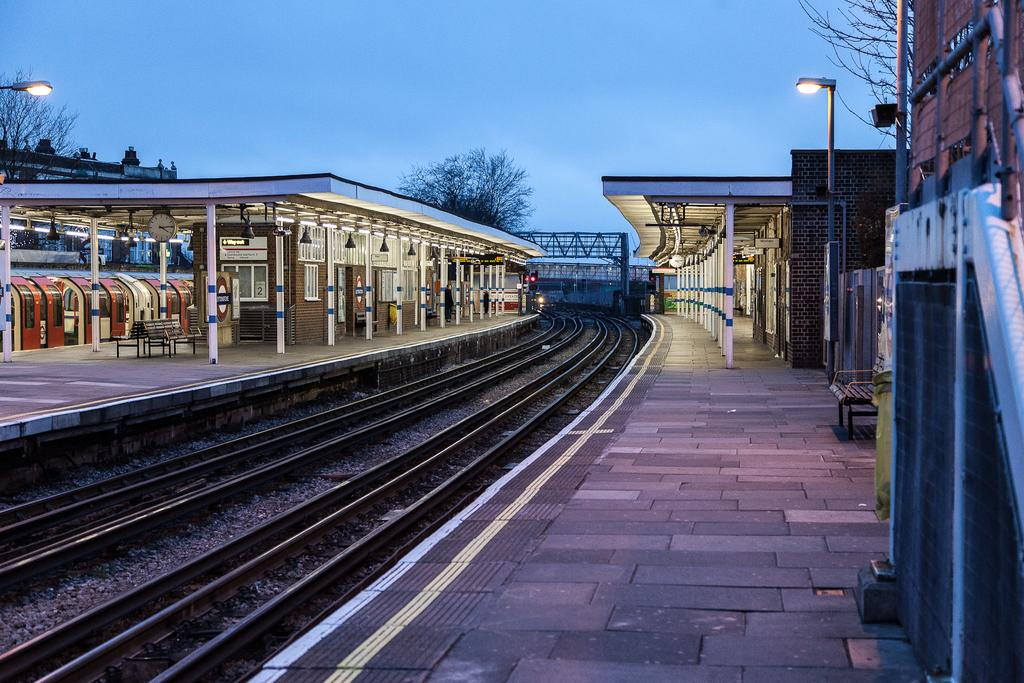Where was the image taken? The image was taken at a railway station. What can be seen on the ground in the image? There is a railway track in the image. What is the main subject of the image? There is a train in the image. What structures are present in the image for illumination? There are light poles in the image. What type of vegetation is visible in the image? There are trees in the image. What type of man-made structures are visible in the image? There are buildings in the image. What type of shelter is available for passengers in the image? There is a roof for shelter in the image. What is visible at the top of the image? The sky is visible at the top of the image. How many weeks does it take for the train to travel around the world in the image? The image does not provide information about the train's travel time or route, so it is impossible to determine how many weeks it would take for the train to travel around the world. 